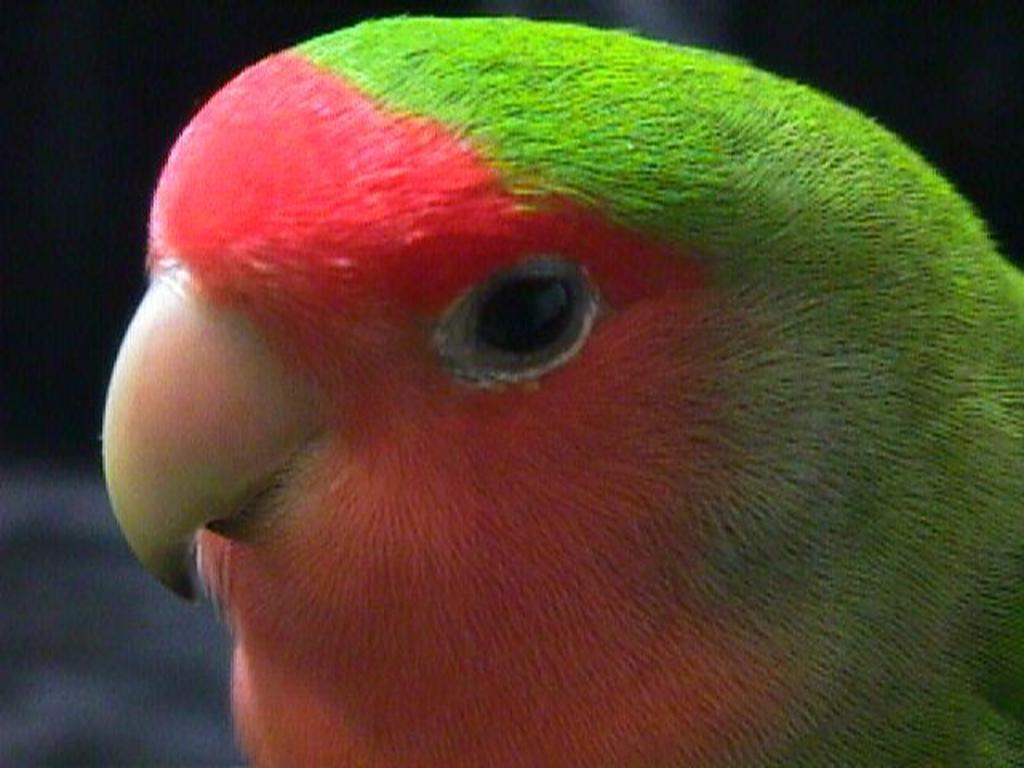In one or two sentences, can you explain what this image depicts? In this picture I can observe a bird looking like parrot. It is in green and red color. The background is blurred. 